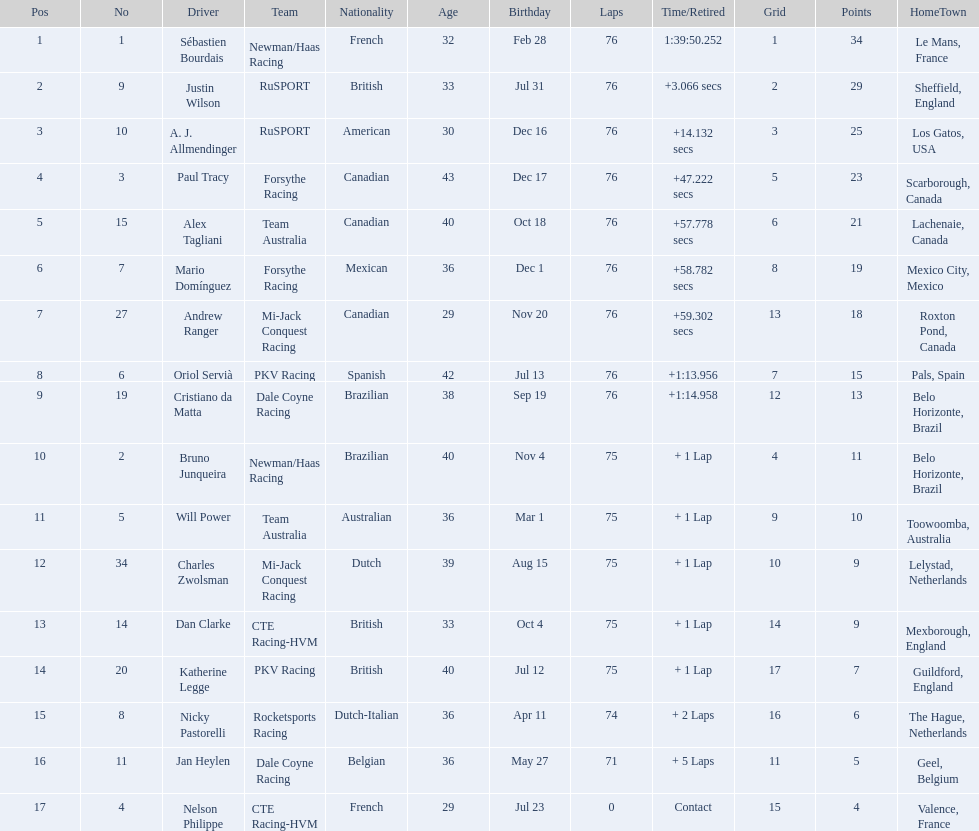How many points did charles zwolsman acquire? 9. Who else got 9 points? Dan Clarke. 